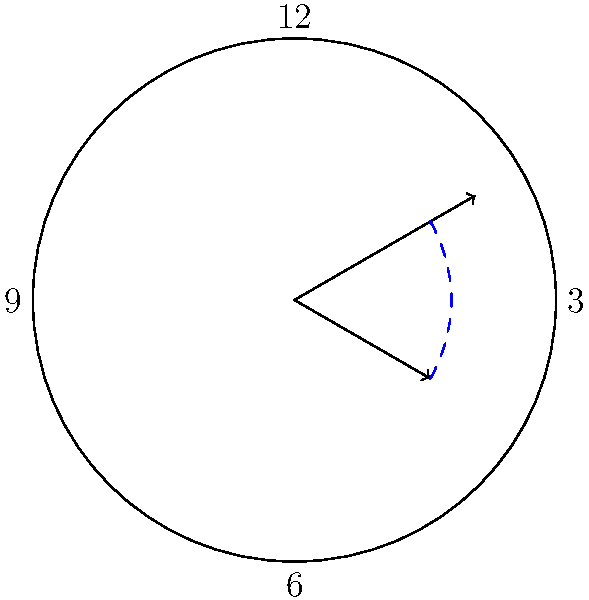In the magical clock in Sabrina's attic, the hour hand points to 2 and the minute hand points to 20 minutes past the hour. What is the measure of the acute angle formed between the hour and minute hands? Let's solve this step-by-step:

1) First, we need to calculate the angle made by each hand from the 12 o'clock position:

   Hour hand: In 12 hours, it rotates 360°. So in 1 hour, it rotates 30°.
   At 2:20, it has rotated: $2 \times 30° + \frac{20}{60} \times 30° = 60° + 10° = 70°$

   Minute hand: In 60 minutes, it rotates 360°. So in 1 minute, it rotates 6°.
   At 20 minutes past, it has rotated: $20 \times 6° = 120°$

2) The angle between the hands is the absolute difference between these angles:
   $|120° - 70°| = 50°$

3) The question asks for the acute angle. If the angle is greater than 180°, we need to subtract it from 360°. In this case, 50° is already acute, so we don't need to do this step.

Therefore, the acute angle between the hour and minute hands is 50°.
Answer: $50°$ 